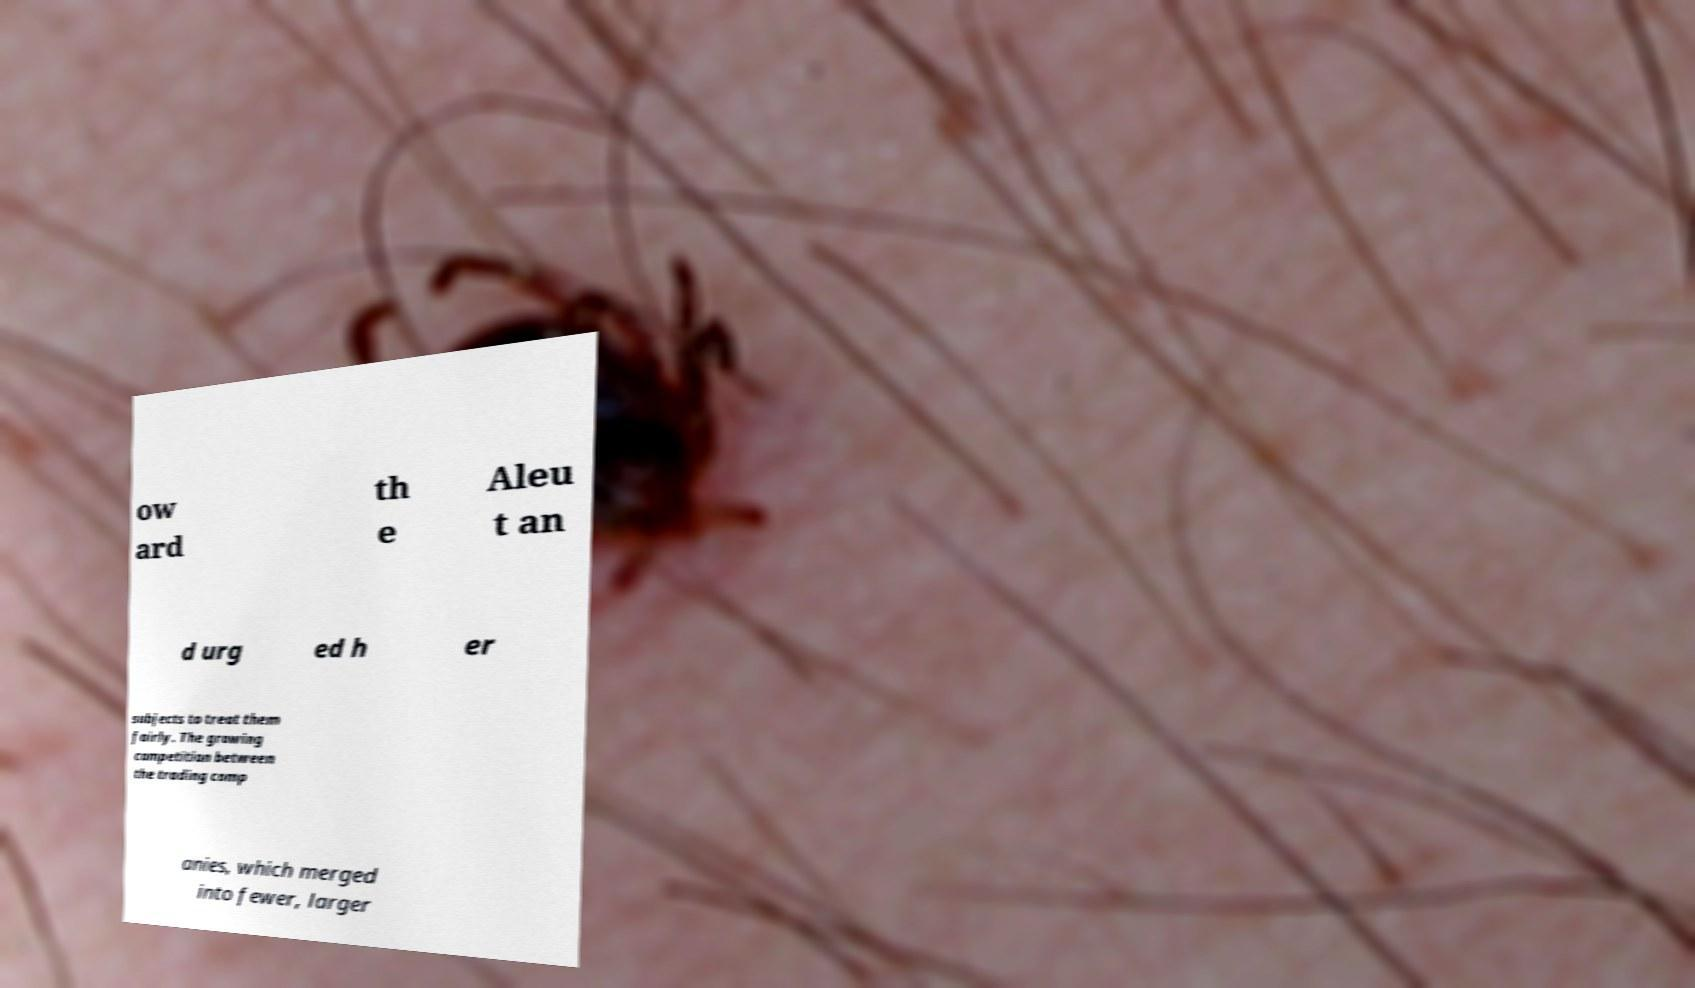Please read and relay the text visible in this image. What does it say? ow ard th e Aleu t an d urg ed h er subjects to treat them fairly. The growing competition between the trading comp anies, which merged into fewer, larger 